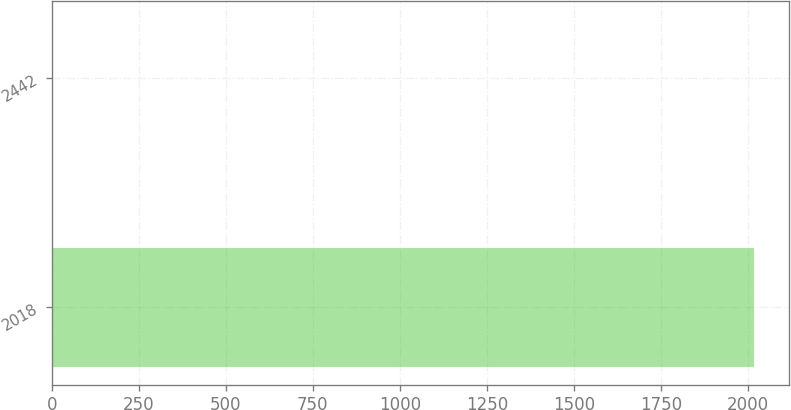<chart> <loc_0><loc_0><loc_500><loc_500><bar_chart><fcel>2018<fcel>2442<nl><fcel>2018<fcel>3.9<nl></chart> 